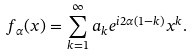<formula> <loc_0><loc_0><loc_500><loc_500>f _ { \alpha } ( x ) = \sum _ { k = 1 } ^ { \infty } a _ { k } e ^ { i 2 \alpha ( 1 - k ) } x ^ { k } .</formula> 